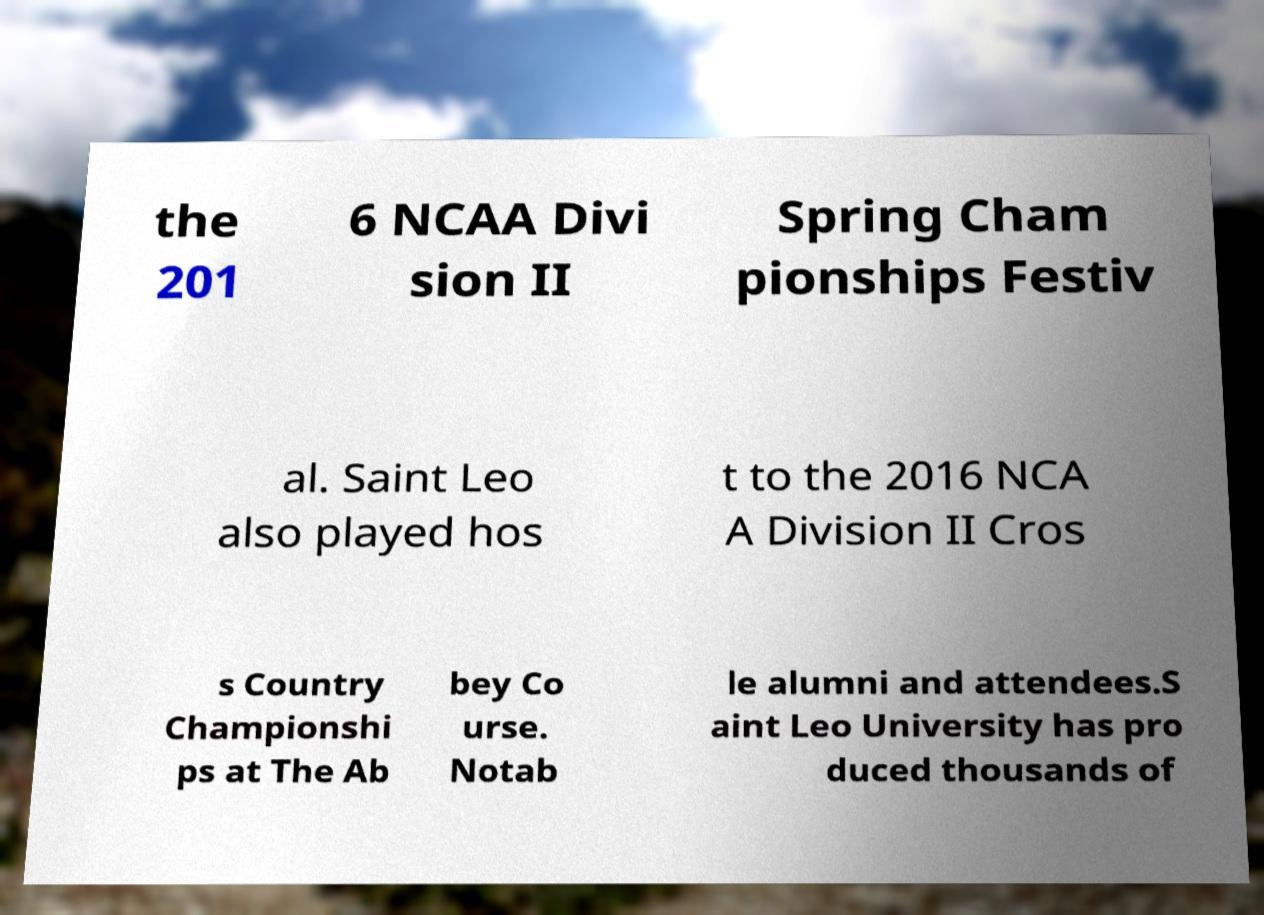What messages or text are displayed in this image? I need them in a readable, typed format. the 201 6 NCAA Divi sion II Spring Cham pionships Festiv al. Saint Leo also played hos t to the 2016 NCA A Division II Cros s Country Championshi ps at The Ab bey Co urse. Notab le alumni and attendees.S aint Leo University has pro duced thousands of 